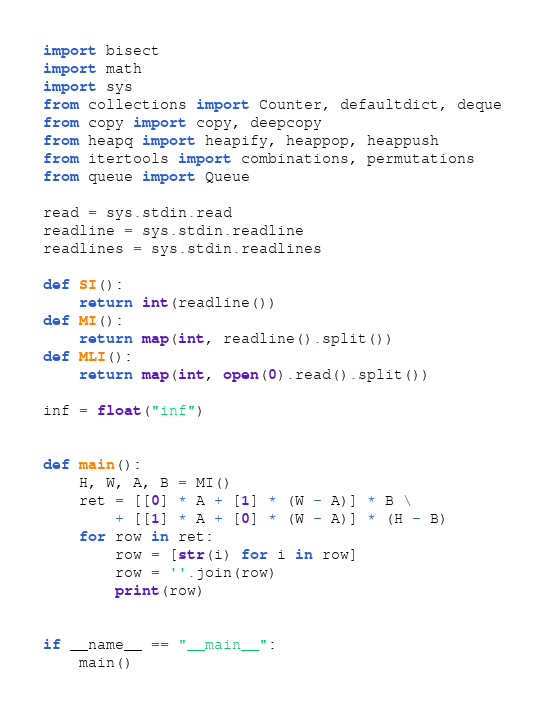Convert code to text. <code><loc_0><loc_0><loc_500><loc_500><_Python_>import bisect
import math
import sys
from collections import Counter, defaultdict, deque
from copy import copy, deepcopy
from heapq import heapify, heappop, heappush
from itertools import combinations, permutations
from queue import Queue

read = sys.stdin.read
readline = sys.stdin.readline 
readlines = sys.stdin.readlines 

def SI():
    return int(readline())
def MI():
    return map(int, readline().split())
def MLI():
    return map(int, open(0).read().split())

inf = float("inf")


def main():
    H, W, A, B = MI()
    ret = [[0] * A + [1] * (W - A)] * B \
    	+ [[1] * A + [0] * (W - A)] * (H - B)
    for row in ret:
        row = [str(i) for i in row]
        row = ''.join(row)
        print(row)
        

if __name__ == "__main__":
    main()</code> 